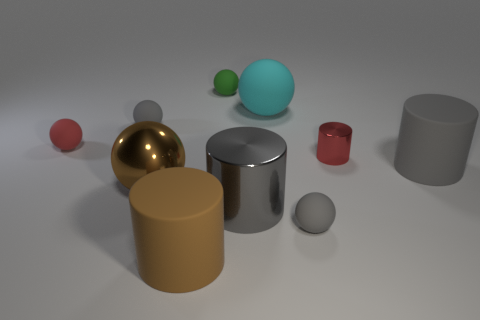There is a red object that is right of the tiny gray matte thing that is behind the small cylinder; how big is it?
Give a very brief answer. Small. There is a metal thing on the left side of the brown cylinder; is it the same size as the large brown rubber object?
Offer a terse response. Yes. Is the number of tiny gray rubber objects on the left side of the large brown matte thing greater than the number of tiny red metal objects to the right of the large brown metallic thing?
Provide a succinct answer. No. The thing that is both to the left of the green thing and in front of the large gray shiny thing has what shape?
Your answer should be very brief. Cylinder. There is a large metal thing behind the gray metallic cylinder; what shape is it?
Your answer should be very brief. Sphere. What size is the brown cylinder in front of the small green matte thing that is behind the gray matte sphere behind the small red cylinder?
Offer a very short reply. Large. Do the big brown metallic object and the gray shiny object have the same shape?
Provide a short and direct response. No. There is a object that is on the left side of the big cyan ball and on the right side of the green sphere; how big is it?
Keep it short and to the point. Large. There is a red thing that is the same shape as the cyan rubber thing; what is its material?
Ensure brevity in your answer.  Rubber. What material is the big brown thing behind the large cylinder to the left of the small green matte object?
Provide a succinct answer. Metal. 